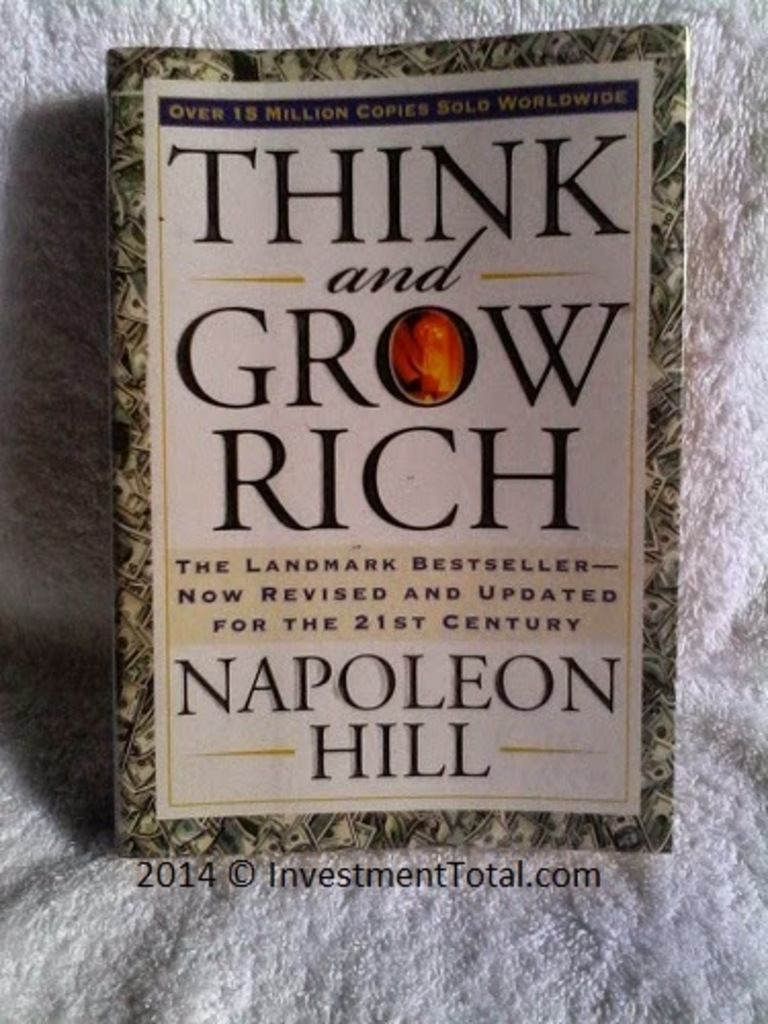Can you describe the main features of this image for me? The image features the book cover of "Think and Grow Rich" by Napoleon Hill. The cover design is ornate, predominantly in green and gold. The title of the book is prominently displayed in large gold letters, while the author's name is presented in smaller gold letters. An emblem in red and gold, containing the word "Rich", is also part of the cover design. This edition of the book is a revised and updated version for the 21st century. The book's popularity is indicated by the text on the cover stating it has sold over 15 million copies worldwide. 